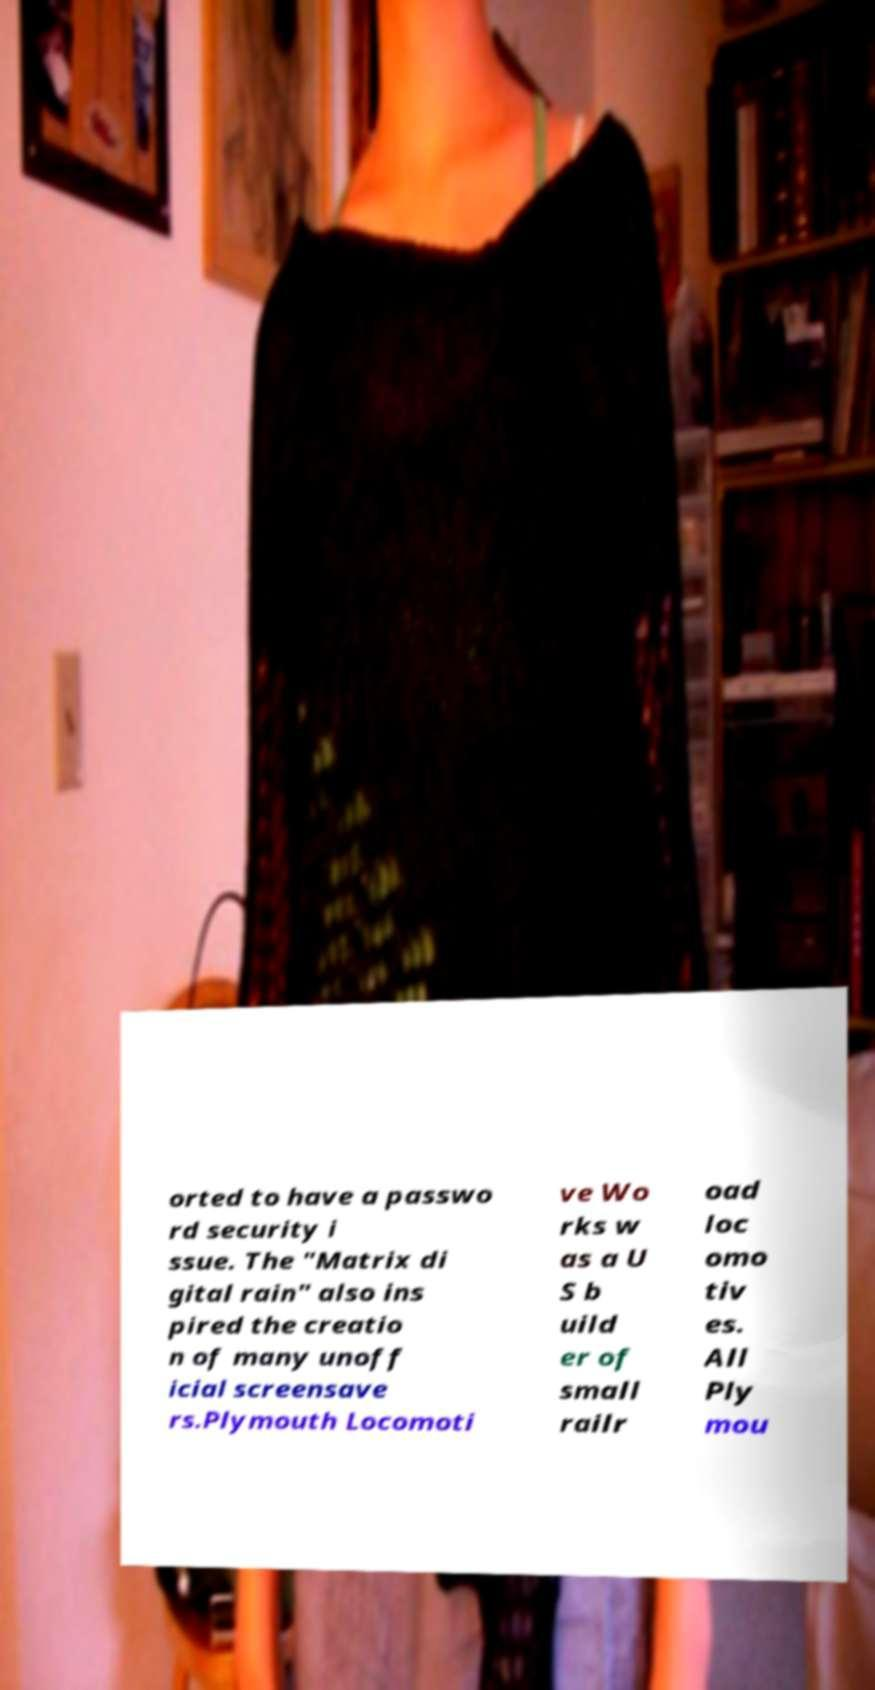Could you extract and type out the text from this image? orted to have a passwo rd security i ssue. The "Matrix di gital rain" also ins pired the creatio n of many unoff icial screensave rs.Plymouth Locomoti ve Wo rks w as a U S b uild er of small railr oad loc omo tiv es. All Ply mou 